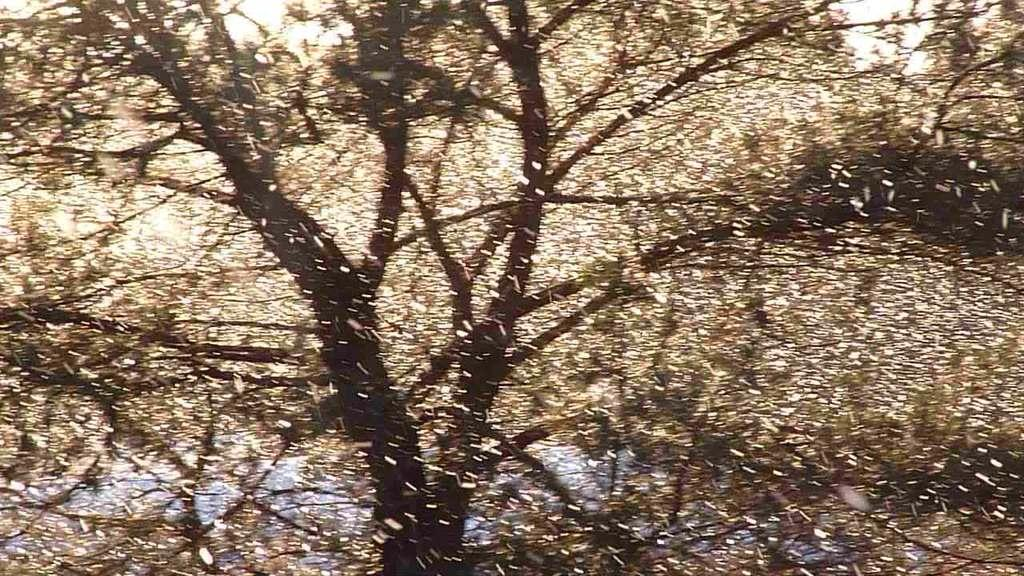What type of plant can be seen in the image? There is a tree in the image. What part of the natural environment is visible in the background of the image? The sky is visible in the background of the image. What type of pain can be seen on the seashore in the image? There is no seashore or pain present in the image; it features a tree and the sky. How is the cream being used in the image? There is no cream present in the image. 